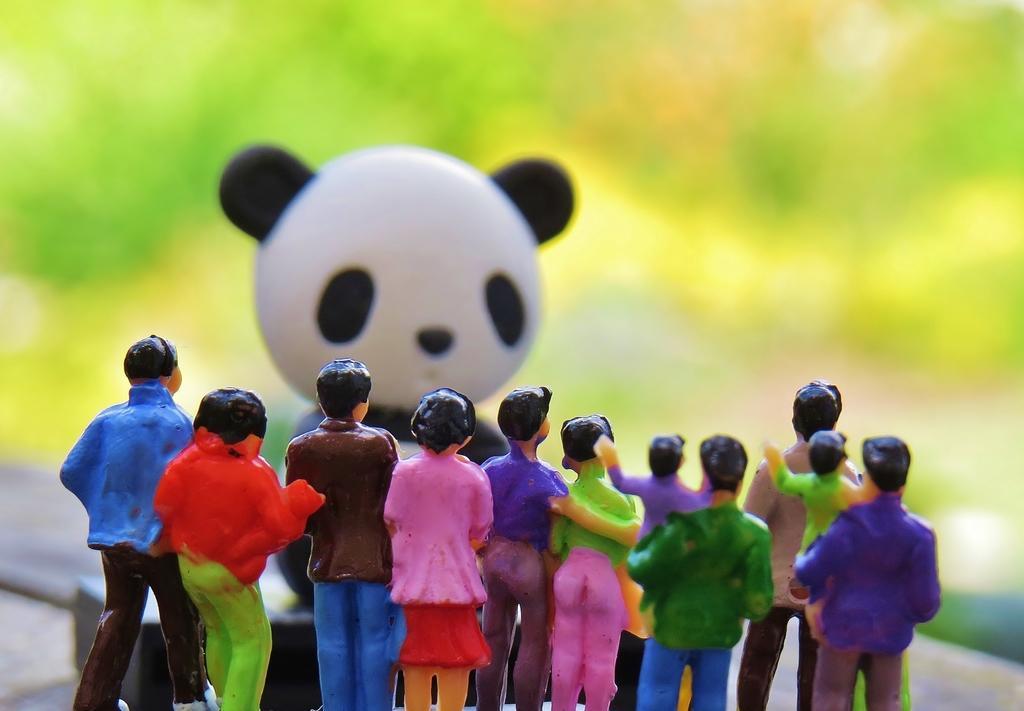Please provide a concise description of this image. In the given image i can see a toys and in the background i can see a greenery. 